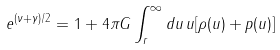<formula> <loc_0><loc_0><loc_500><loc_500>e ^ { ( \nu + \gamma ) / 2 } = 1 + 4 \pi G \int _ { r } ^ { \infty } d u \, u [ \rho ( u ) + p ( u ) ]</formula> 